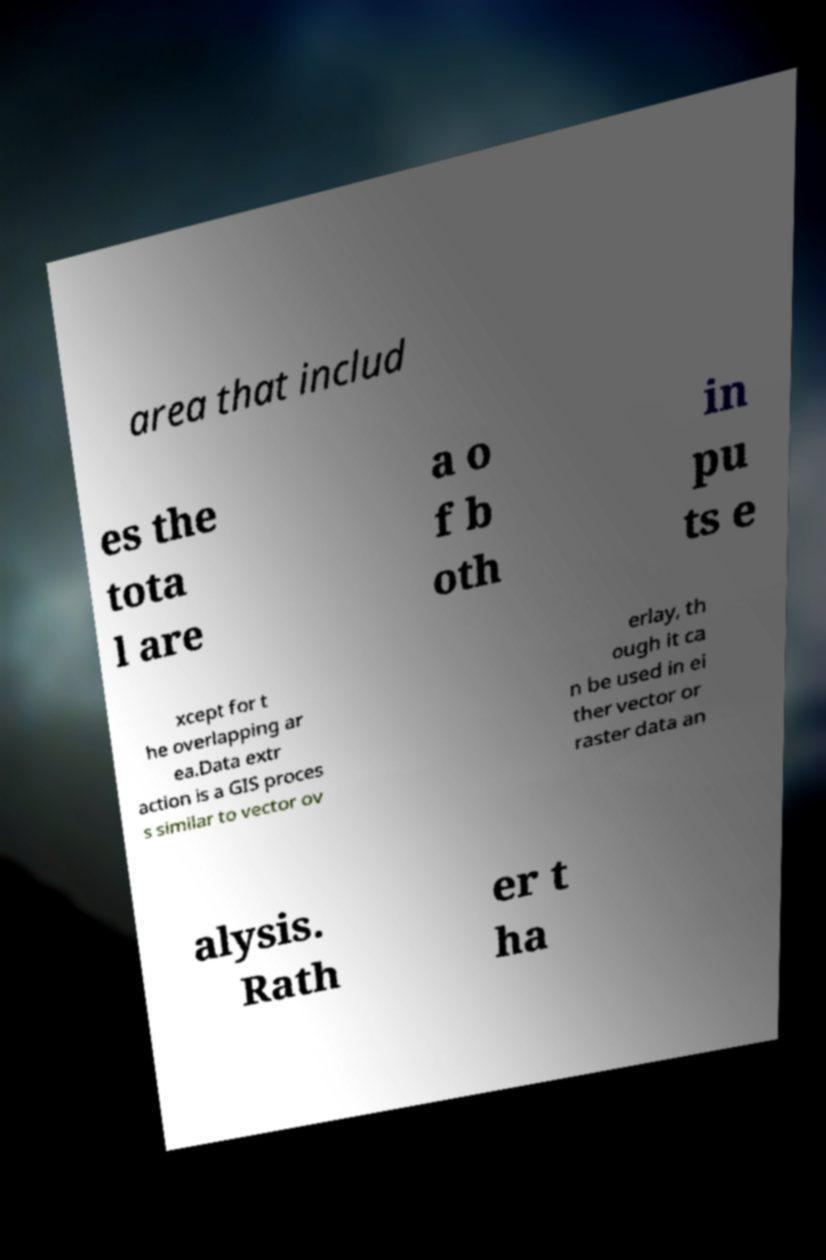Can you accurately transcribe the text from the provided image for me? area that includ es the tota l are a o f b oth in pu ts e xcept for t he overlapping ar ea.Data extr action is a GIS proces s similar to vector ov erlay, th ough it ca n be used in ei ther vector or raster data an alysis. Rath er t ha 